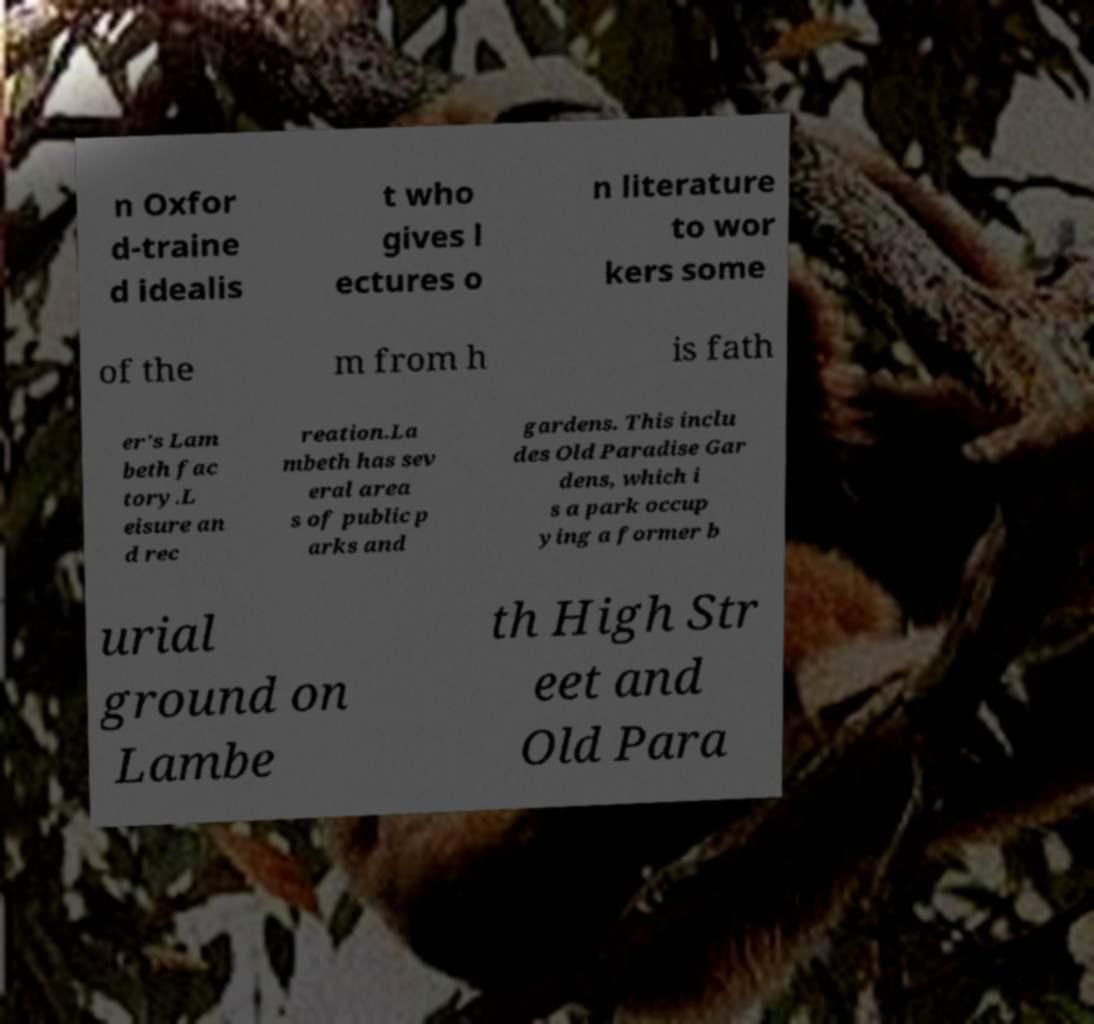There's text embedded in this image that I need extracted. Can you transcribe it verbatim? n Oxfor d-traine d idealis t who gives l ectures o n literature to wor kers some of the m from h is fath er's Lam beth fac tory.L eisure an d rec reation.La mbeth has sev eral area s of public p arks and gardens. This inclu des Old Paradise Gar dens, which i s a park occup ying a former b urial ground on Lambe th High Str eet and Old Para 